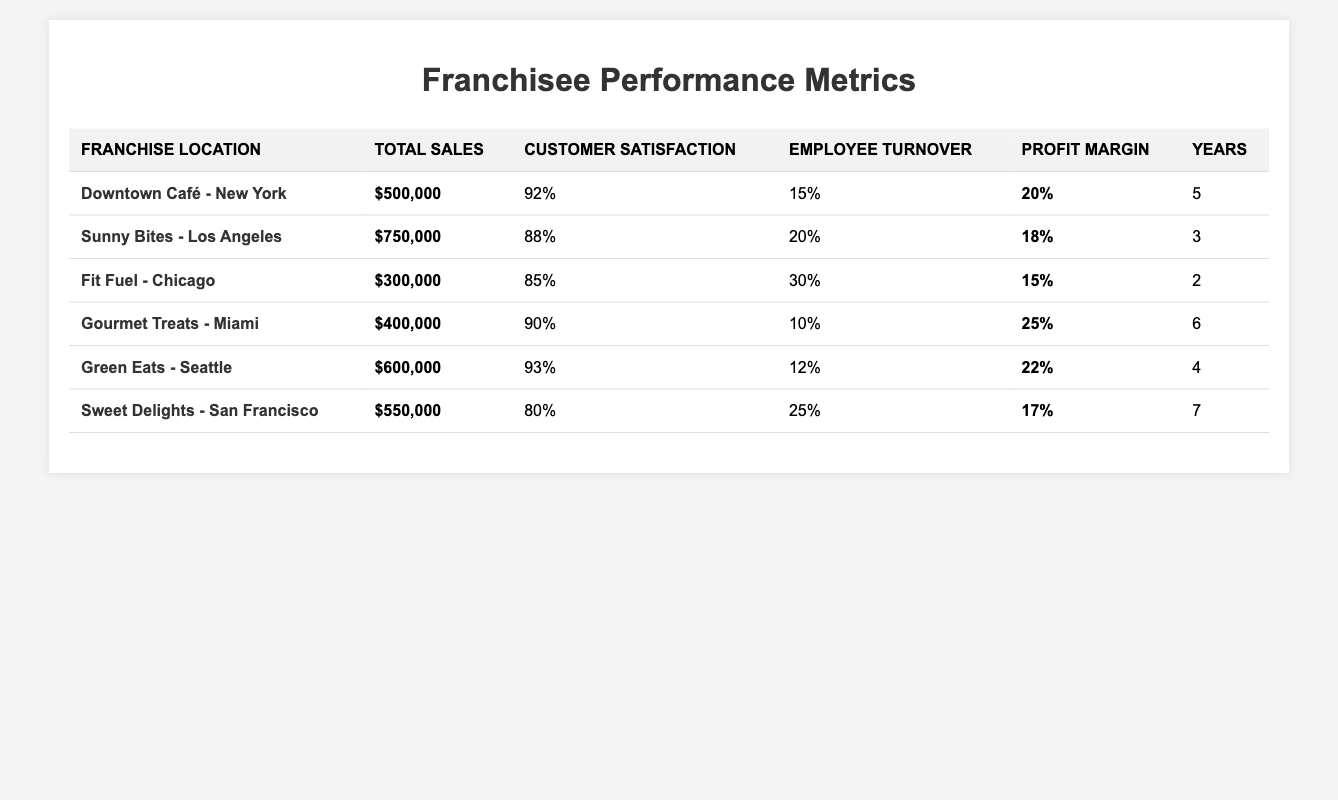What is the total sales amount for Gourmet Treats - Miami? The table indicates that the total sales for Gourmet Treats - Miami is directly listed as $400,000.
Answer: $400,000 Which franchise has the highest customer satisfaction score? By comparing the customer satisfaction scores provided for each franchise, Green Eats - Seattle shows the highest score at 93%.
Answer: Green Eats - Seattle What is the average profit margin across all franchises? To find the average profit margin, we sum the profit margins (20% + 18% + 15% + 25% + 22% + 17% = 117%) and divide by the number of franchises (6). Thus, 117% / 6 = 19.5%.
Answer: 19.5% Is it true that Sweet Delights - San Francisco has a lower total sales than Fit Fuel - Chicago? Evaluating the total sales, Sweet Delights has $550,000 while Fit Fuel has $300,000, indicating that Sweet Delights has higher sales. Therefore, the statement is false.
Answer: False What is the difference in employee turnover rate between Downtown Café - New York and Sunny Bites - Los Angeles? The employee turnover rate for Downtown Café is 15%, and for Sunny Bites, it is 20%. The difference is calculated as 20% - 15% = 5%.
Answer: 5% Which two franchises have the longest operational years? Looking at the years of operation, Sweet Delights and Gourmet Treats are the only franchises with operational durations of 7 and 6 years respectively, making them the longest operational.
Answer: Sweet Delights and Gourmet Treats What is the total sales amount for franchises that have a profit margin above 20%? The franchises with a profit margin above 20% are Gourmet Treats (25%) and Green Eats (22%), with sales of $400,000 and $600,000 respectively. Adding these yields $400,000 + $600,000 = $1,000,000.
Answer: $1,000,000 How many franchises have an employee turnover rate of more than 20%? By reviewing the turnover rates, Fit Fuel (30%), Sunny Bites (20%), and Sweet Delights (25%) are noted. Only Fit Fuel and Sweet Delights exceed 20%, totaling 2 franchises.
Answer: 2 If we consider the top three franchises by total sales, what is their average customer satisfaction score? The top three franchises by total sales are Sunny Bites ($750,000), Green Eats ($600,000), and Sweet Delights ($550,000). Their customer satisfaction scores are 88%, 93%, and 80%, respectively. The average satisfaction score is calculated as (88 + 93 + 80) / 3 = 87%.
Answer: 87% Which franchise has the highest profit margin and what is that margin? Upon reviewing the profit margins listed, Gourmet Treats has the highest profit margin of 25%.
Answer: 25% 